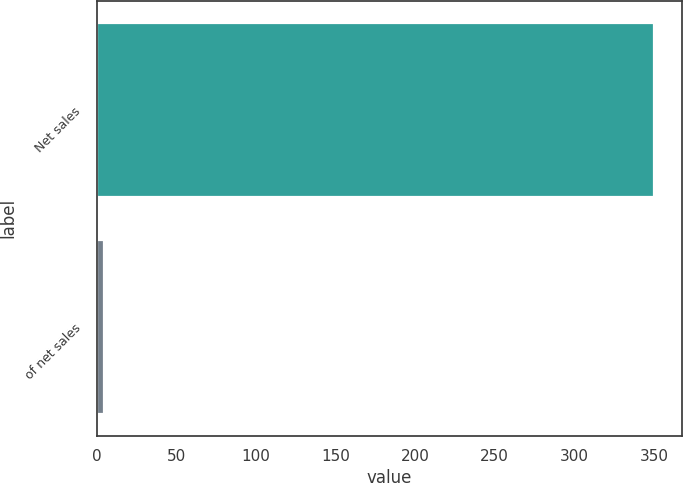Convert chart. <chart><loc_0><loc_0><loc_500><loc_500><bar_chart><fcel>Net sales<fcel>of net sales<nl><fcel>350.1<fcel>4.7<nl></chart> 